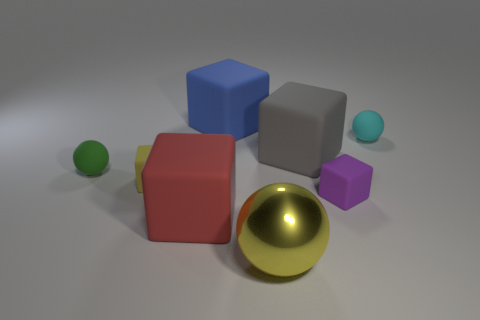Add 1 metal balls. How many objects exist? 9 Subtract all balls. How many objects are left? 5 Subtract all blue matte blocks. Subtract all gray matte things. How many objects are left? 6 Add 5 big gray objects. How many big gray objects are left? 6 Add 6 large yellow spheres. How many large yellow spheres exist? 7 Subtract 0 cyan blocks. How many objects are left? 8 